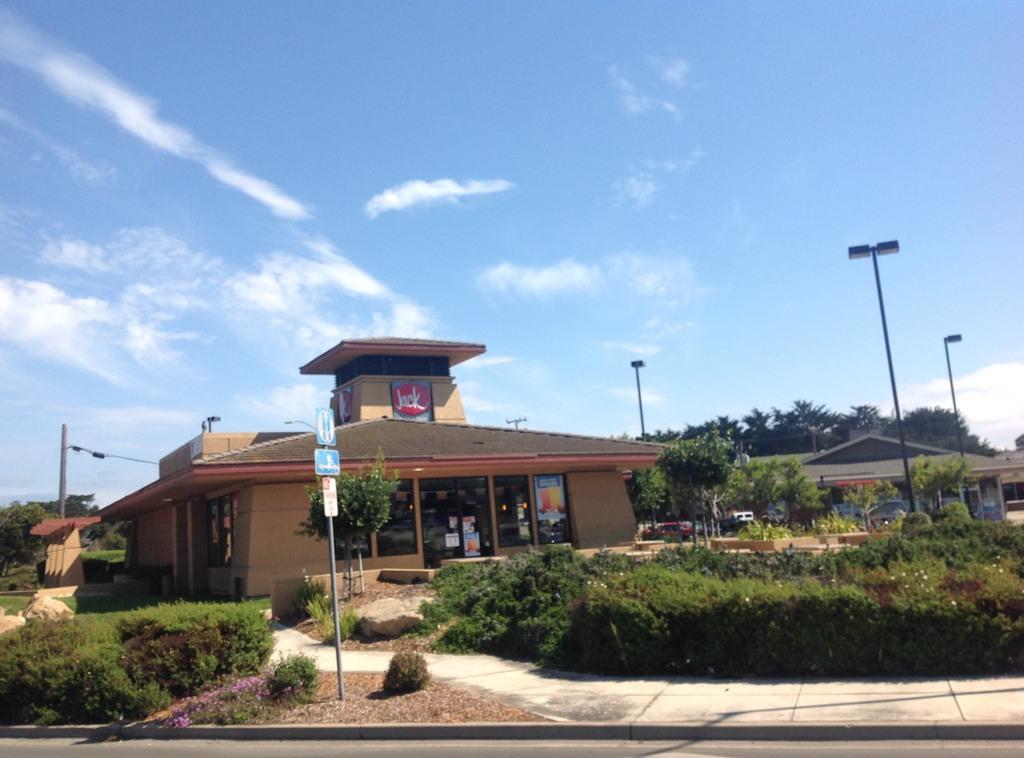Can you describe this image briefly? At the center of the image there is a building, in front of the building there are trees and some utility poles. In the background there is a sky. 